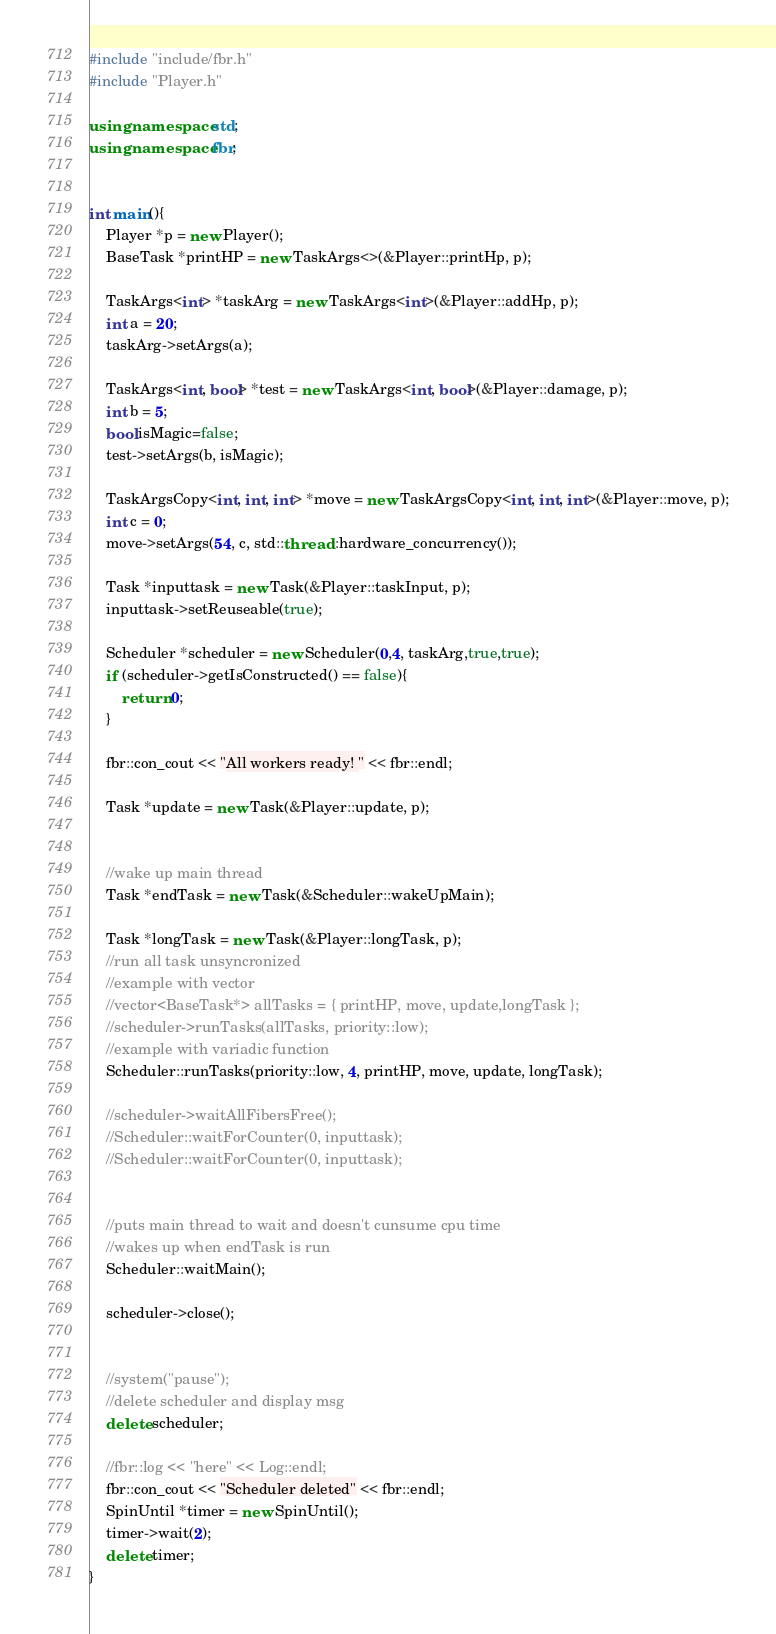<code> <loc_0><loc_0><loc_500><loc_500><_C++_>#include "include/fbr.h"
#include "Player.h"

using namespace std;
using namespace fbr;


int main(){
	Player *p = new Player();
	BaseTask *printHP = new TaskArgs<>(&Player::printHp, p);

	TaskArgs<int> *taskArg = new TaskArgs<int>(&Player::addHp, p);
	int a = 20;
	taskArg->setArgs(a);

	TaskArgs<int, bool> *test = new TaskArgs<int, bool>(&Player::damage, p);
	int b = 5;
	bool isMagic=false;
	test->setArgs(b, isMagic);

	TaskArgsCopy<int, int, int> *move = new TaskArgsCopy<int, int, int>(&Player::move, p);
	int c = 0;
	move->setArgs(54, c, std::thread::hardware_concurrency());

	Task *inputtask = new Task(&Player::taskInput, p);
	inputtask->setReuseable(true);

	Scheduler *scheduler = new Scheduler(0,4, taskArg,true,true);
	if (scheduler->getIsConstructed() == false){
		return 0;
	}

	fbr::con_cout << "All workers ready! " << fbr::endl;

	Task *update = new Task(&Player::update, p);
	

	//wake up main thread
	Task *endTask = new Task(&Scheduler::wakeUpMain);

	Task *longTask = new Task(&Player::longTask, p);
	//run all task unsyncronized
	//example with vector
	//vector<BaseTask*> allTasks = { printHP, move, update,longTask };
	//scheduler->runTasks(allTasks, priority::low);
	//example with variadic function
	Scheduler::runTasks(priority::low, 4, printHP, move, update, longTask);

	//scheduler->waitAllFibersFree();  
	//Scheduler::waitForCounter(0, inputtask);
	//Scheduler::waitForCounter(0, inputtask);


	//puts main thread to wait and doesn't cunsume cpu time
	//wakes up when endTask is run
	Scheduler::waitMain();

	scheduler->close();
	
	
	//system("pause");
	//delete scheduler and display msg
	delete scheduler;
	
	//fbr::log << "here" << Log::endl;
	fbr::con_cout << "Scheduler deleted" << fbr::endl;
	SpinUntil *timer = new SpinUntil();
	timer->wait(2);
	delete timer;
}</code> 